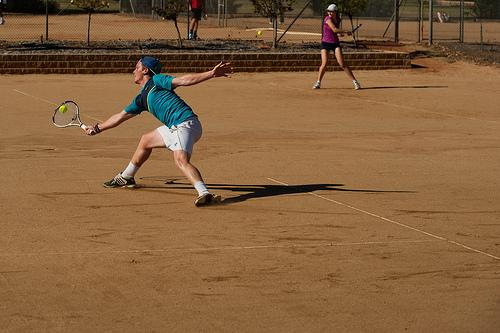Identify the sport being played by the people in the image. The sport being played in the image is tennis. Using the information provided, describe the two main tennis players. There is a man wearing a blue shirt, blue baseball cap, teal shirt, and tan shorts lunging to hit a tennis ball; and a woman wearing a purple short-sleeved shirt, black shorts, and a white cap preparing to return the ball with her racquet. What is the tennis court surface made of? The tennis court surface is made of clay. Name the colors of both the man and the woman's shirts. The man's shirt is blue and the woman's shirt is purple. Describe the tennis ball's position relative to the man's racket. The tennis ball is in close proximity to the man's racket, and about to make contact. Identify a distinguishing feature of the man's attire. A distinguishing feature of the man's attire is his blue baseball cap worn backwards. What color is the tennis ball? The tennis ball is bright yellow. What is the position of the woman's right arm in the picture? The woman's right arm is twisted across her body. Identify a detail about the tennis players' shoes or accessories. The person on the other side of the fence is wearing blue shoes. Provide a summary of the scene in the image. Two tennis players are playing on a clay court, with the man lunging to make contact with the ball and the woman preparing for her next move. Describe the tennis court in the image. An earthen tennis court with white lines and a clay surface. Scan the image for any textual content present within it. There is no textual content in the image. What led you to conclude that the sport being played is tennis? The presence of a tennis court, tennis racquets, and tennis balls. Reveal the colors of the sports attire worn by the woman in the image. Purple short-sleeved shirt and black shorts. What color is the shirt the man is wearing while playing tennis in the image? Blue List down the objects held by both tennis players. Tennis racquets. Give a comprehensive description of the man in the image. The man is wearing a blue shirt, tan shorts, and a blue baseball cap turned backwards. He is lunging to hit the tennis ball with his left arm stretched behind him and his legs spread wide apart. What can you infer from the shadow of the man on the court? The sun is shining from the left side, casting his shadow in the opposite direction. Select the correct statement regarding the position of the tennis ball in relation to the man's racquet. b) The ball is far away from the racket. How would you describe the woman's stance in the image? She is standing near the white line with her right arm twisted across her body and her knees pointed inwards. Identify the emotions displayed by the two people playing tennis. Not enough facial feature details to detect emotions. Describe the context and activities within the image related to tennis. The image shows a moment during a tennis match, where the man is lunging to make contact with the ball, while the woman prepares her stance for the next move, on a clay court. Which of the following statements accurately summarizes the position of the tennis ball in the image?  b) The tennis ball is in contact with the man's racket. Examine the image and identify the players' positioning. The man has his legs spread wide apart and is lunging to make contact with the ball, while the woman is standing near the white line with her right arm twisted across her body. Point out the colors of the shorts the tennis players are wearing. The man's shorts are tan, while the woman's shorts are black. Create a storyline for the image showing a tennis match. A couple on a summer afternoon decided to have a friendly tennis match on a clay court. The man, wearing a blue shirt and tan shorts, is returning the ball towards the woman, who is dressed in a purple shirt and black shorts. Excitement builds as they anticipate each other's moves and compete with enthusiasm. In the provided image, write a caption describing the scene. Two people engaging in a tennis match on a clay court, with the man lunging to hit the ball while the woman prepares her next move. 